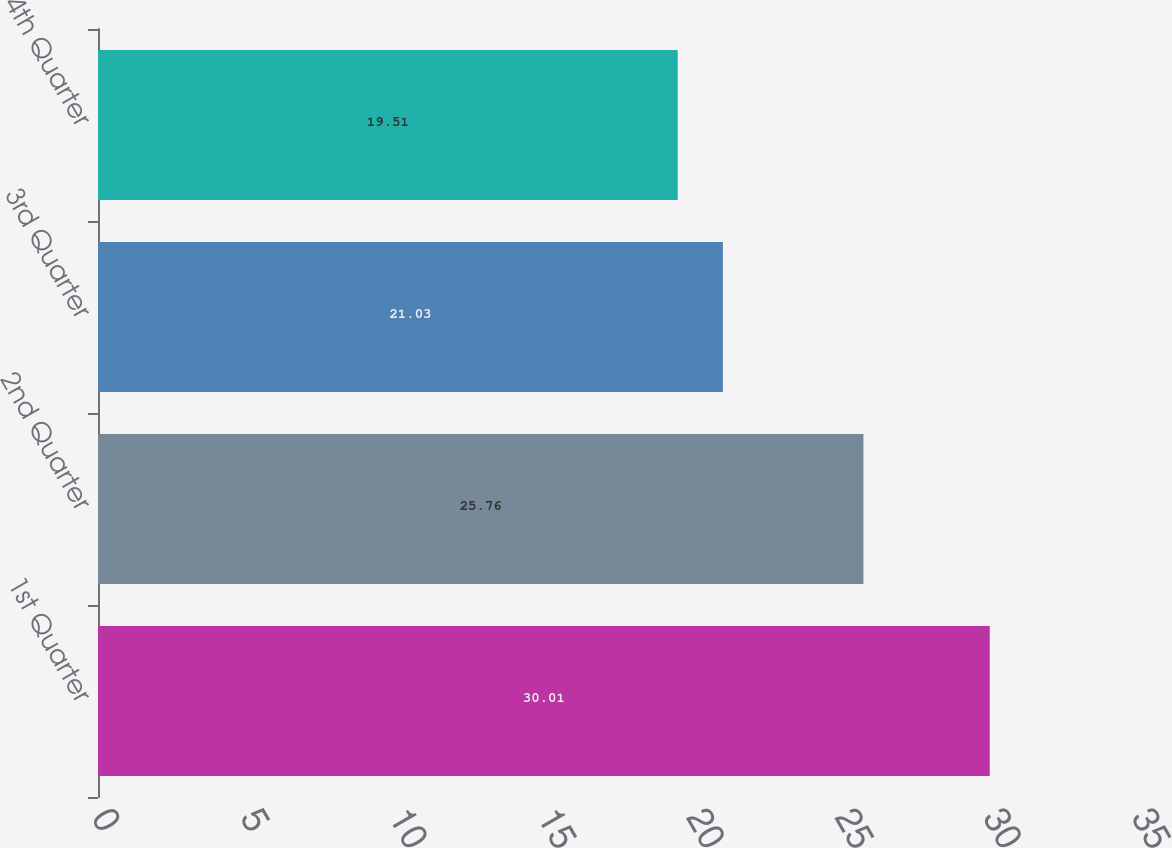Convert chart to OTSL. <chart><loc_0><loc_0><loc_500><loc_500><bar_chart><fcel>1st Quarter<fcel>2nd Quarter<fcel>3rd Quarter<fcel>4th Quarter<nl><fcel>30.01<fcel>25.76<fcel>21.03<fcel>19.51<nl></chart> 